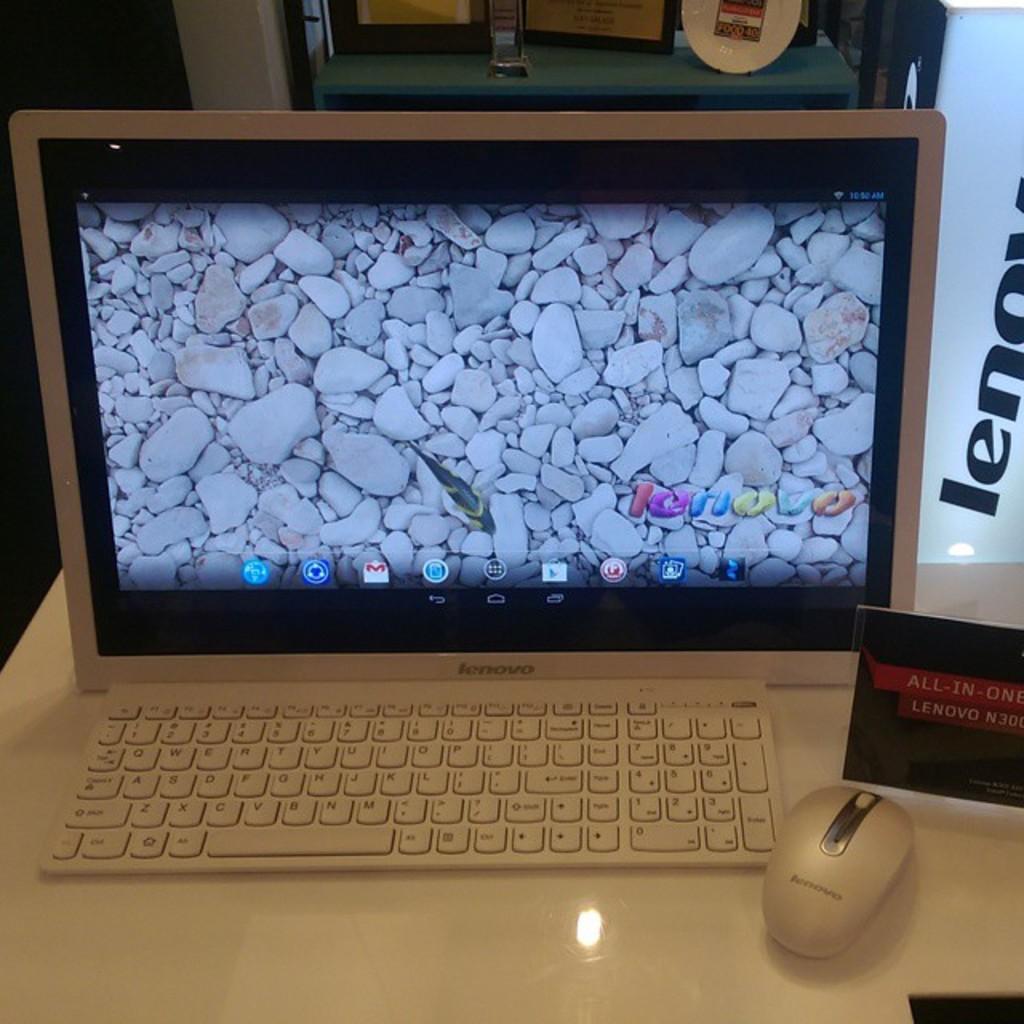What is the brand on display?
Make the answer very short. Lenovo. 